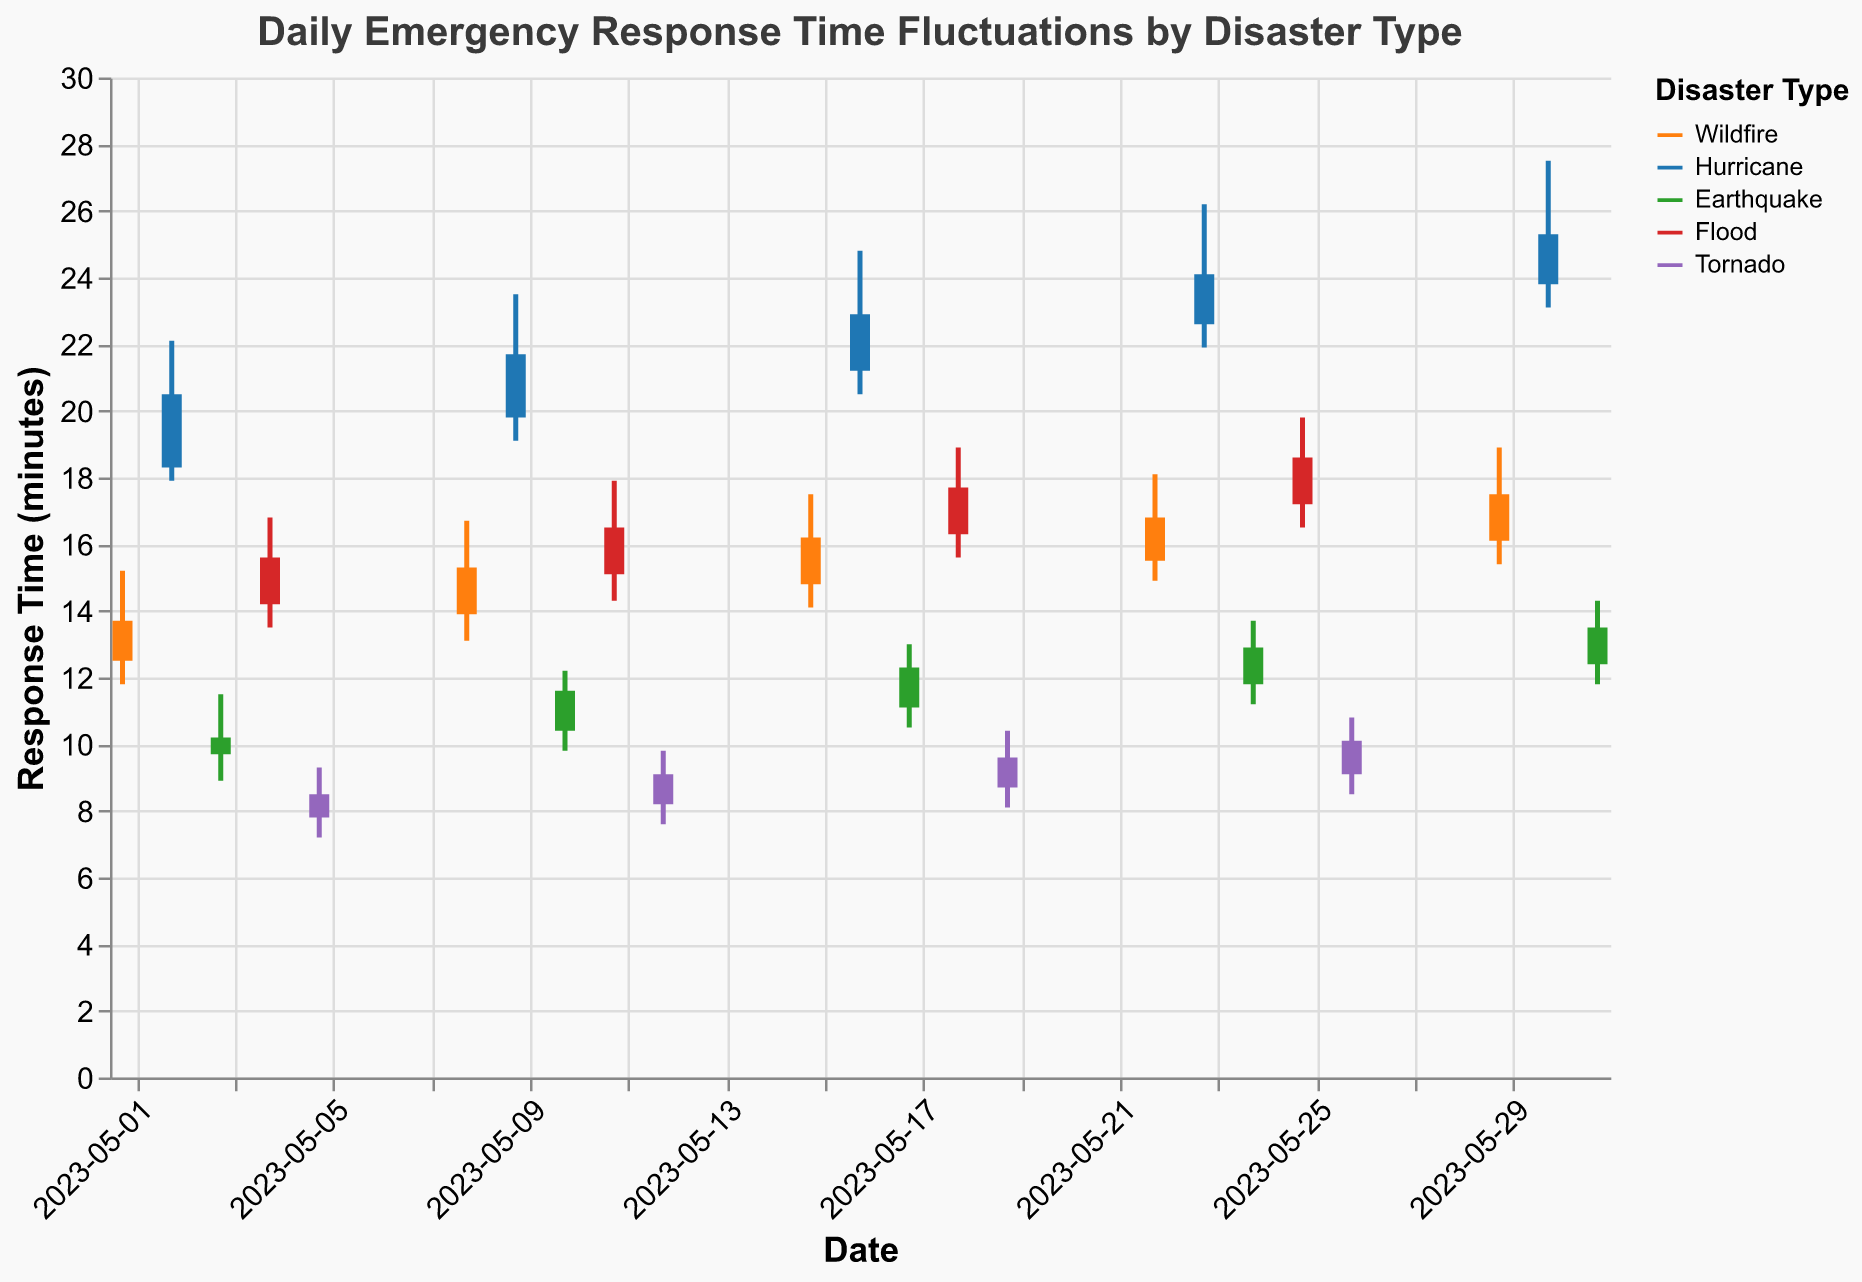What is the highest response time recorded for a Hurricane? The highest response time for a Hurricane can be found by looking for the maximum 'High' value associated with the Hurricane disaster type. Inspecting the chart, the highest 'High' value for a Hurricane is 27.5 minutes on May 30.
Answer: 27.5 minutes Which disaster type has the lowest 'Open' response time, and what is that time? The lowest 'Open' response time across all disaster types can be found by comparing the 'Open' values. Tornado has the lowest 'Open' response time with a value of 7.8 minutes on May 5.
Answer: Tornado, 7.8 minutes On which date did Wildfire have the highest 'Close' response time, and what was it? To determine the date, look at the 'Close' values associated with the Wildfire disaster type. The highest 'Close' value for Wildfire is 17.5 minutes on May 29.
Answer: May 29, 17.5 minutes What is the average 'Close' response time for the Earthquake disaster type? To find the average 'Close' response time for Earthquake, add all the 'Close' values for Earthquake and divide by the number of dates. The sum is 10.2 + 11.6 + 12.3 + 12.9 + 13.5 = 60.5. There are 5 dates, so the average is 60.5 / 5 = 12.1 minutes.
Answer: 12.1 minutes Which disaster type showed the largest difference between 'High' and 'Low' response times, and what is the difference? The difference between 'High' and 'Low' response times can be calculated for each disaster type, and the largest difference identified. Hurricane on May 30 shows the largest difference: 27.5 - 23.1 = 4.4 minutes.
Answer: Hurricane, 4.4 minutes Between May 11 and May 18, which disaster type experienced the greatest increase in 'Close' response time? Comparing the 'Close' response times for all disaster types on May 11 and May 18, Flood shows the greatest increase from 16.5 to 17.7 minutes, a difference of 1.2 minutes.
Answer: Flood, 1.2 minutes What trend can be observed in the 'Close' response times for Wildfire throughout the month? Analyzing the 'Close' response times for Wildfire on each recorded date (13.7, 15.3, 16.2, 16.8, 17.5), we see a general increasing trend throughout the month of May.
Answer: Increasing trend How many disaster types have 'Close' response times above 20 minutes on any given date? By inspecting the chart, Hurricane consistently has 'Close' response times above 20 minutes on multiple dates (May 2, May 9, May 16, May 23, May 30). Only Hurricane exceeds 20 minutes.
Answer: One (Hurricane) 